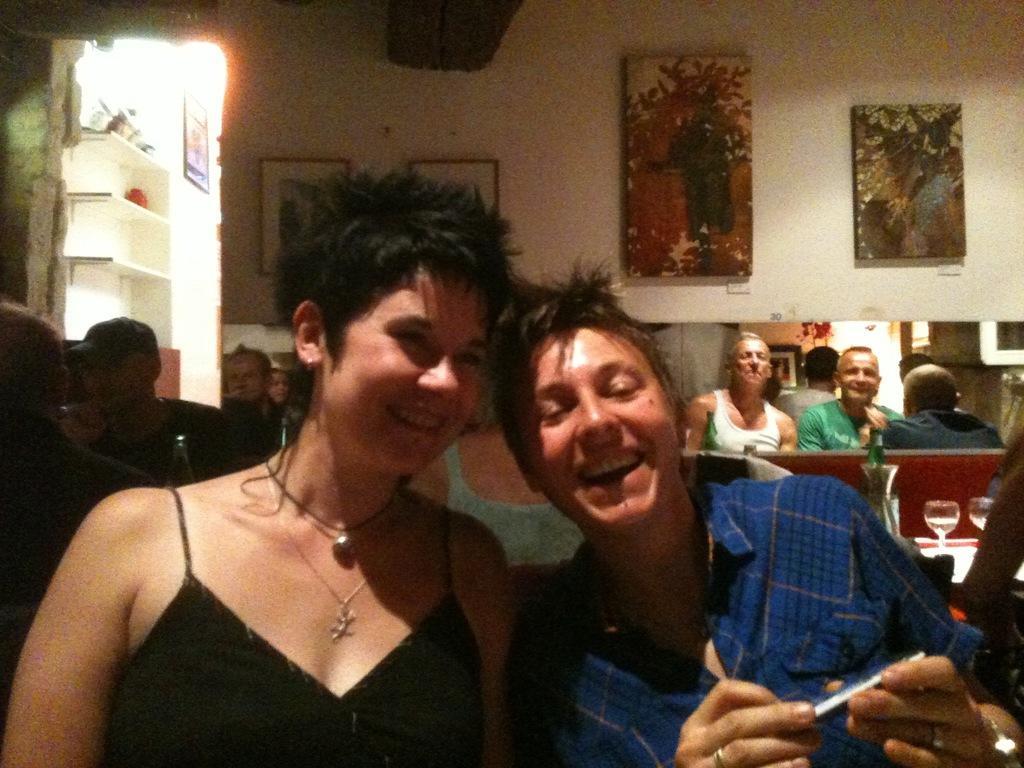Can you describe this image briefly? In the center of the image, we can see two persons smiling and in the background, there are some other persons and there are frames placed on the wall. 